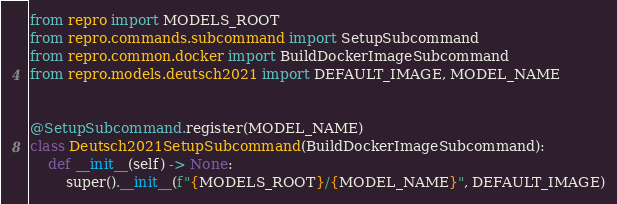Convert code to text. <code><loc_0><loc_0><loc_500><loc_500><_Python_>from repro import MODELS_ROOT
from repro.commands.subcommand import SetupSubcommand
from repro.common.docker import BuildDockerImageSubcommand
from repro.models.deutsch2021 import DEFAULT_IMAGE, MODEL_NAME


@SetupSubcommand.register(MODEL_NAME)
class Deutsch2021SetupSubcommand(BuildDockerImageSubcommand):
    def __init__(self) -> None:
        super().__init__(f"{MODELS_ROOT}/{MODEL_NAME}", DEFAULT_IMAGE)
</code> 